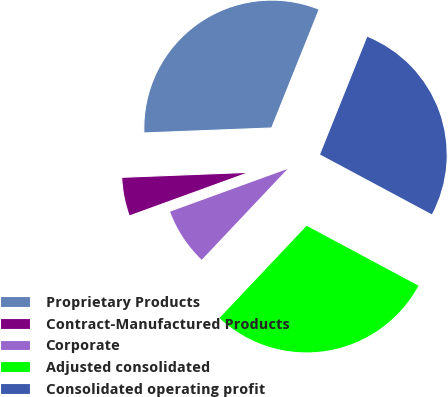Convert chart to OTSL. <chart><loc_0><loc_0><loc_500><loc_500><pie_chart><fcel>Proprietary Products<fcel>Contract-Manufactured Products<fcel>Corporate<fcel>Adjusted consolidated<fcel>Consolidated operating profit<nl><fcel>31.69%<fcel>4.93%<fcel>7.4%<fcel>29.22%<fcel>26.75%<nl></chart> 